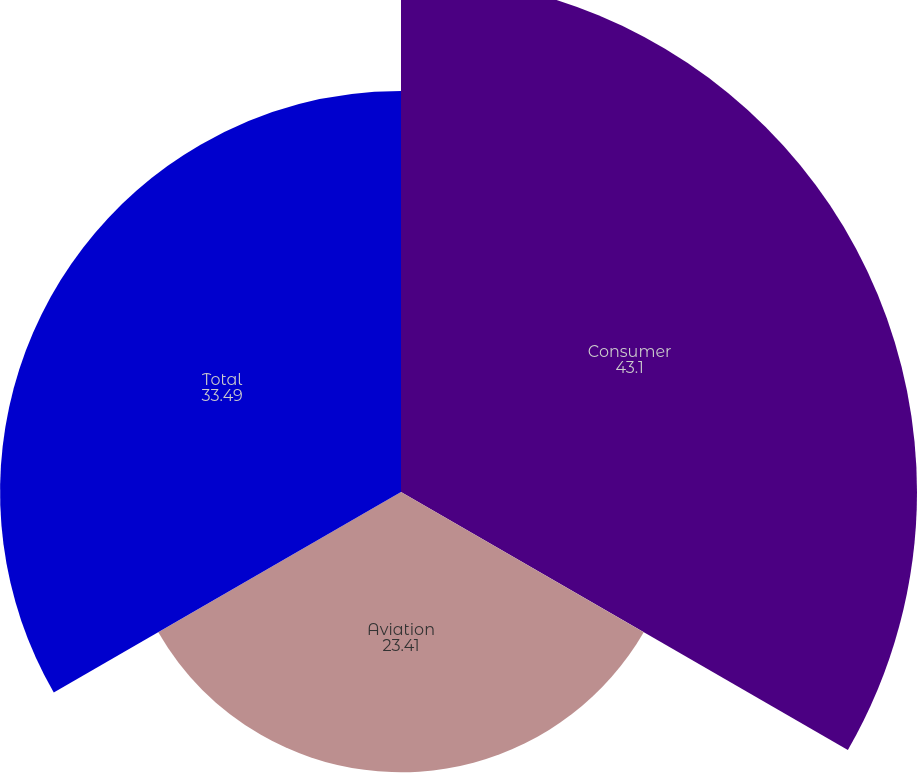<chart> <loc_0><loc_0><loc_500><loc_500><pie_chart><fcel>Consumer<fcel>Aviation<fcel>Total<nl><fcel>43.1%<fcel>23.41%<fcel>33.49%<nl></chart> 